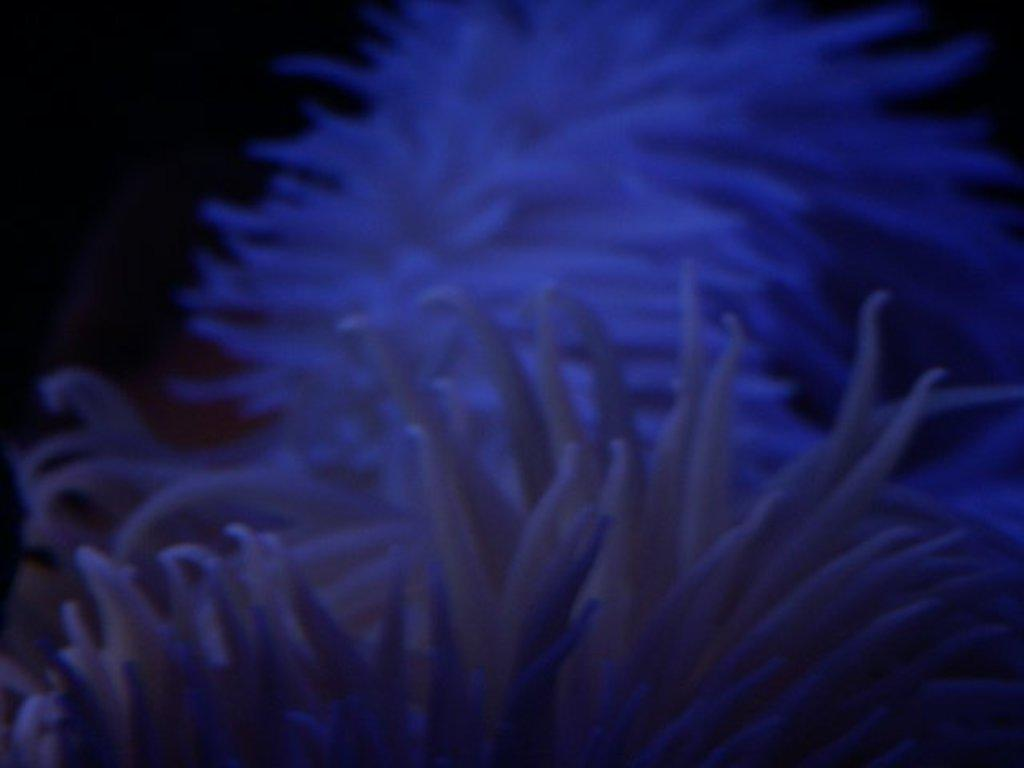What is the main subject of the image? The main subject of the image is flowers. Can you describe the flowers in the image? The flowers are located in the center of the image. What type of advertisement can be seen featuring a crying machine in the image? There is no advertisement, crying, or machine present in the image; it features flowers in the center. 